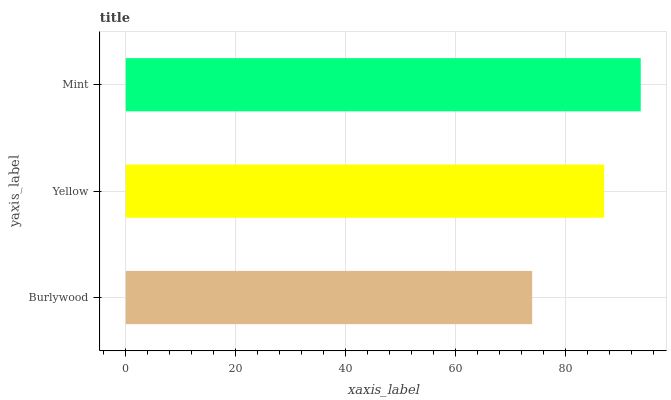Is Burlywood the minimum?
Answer yes or no. Yes. Is Mint the maximum?
Answer yes or no. Yes. Is Yellow the minimum?
Answer yes or no. No. Is Yellow the maximum?
Answer yes or no. No. Is Yellow greater than Burlywood?
Answer yes or no. Yes. Is Burlywood less than Yellow?
Answer yes or no. Yes. Is Burlywood greater than Yellow?
Answer yes or no. No. Is Yellow less than Burlywood?
Answer yes or no. No. Is Yellow the high median?
Answer yes or no. Yes. Is Yellow the low median?
Answer yes or no. Yes. Is Burlywood the high median?
Answer yes or no. No. Is Mint the low median?
Answer yes or no. No. 